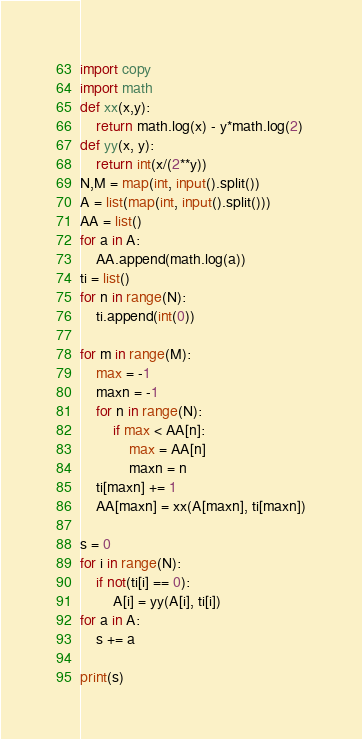Convert code to text. <code><loc_0><loc_0><loc_500><loc_500><_Python_>import copy
import math
def xx(x,y):
    return math.log(x) - y*math.log(2)
def yy(x, y):
    return int(x/(2**y))
N,M = map(int, input().split())
A = list(map(int, input().split()))
AA = list()
for a in A:
    AA.append(math.log(a))
ti = list()
for n in range(N):
    ti.append(int(0))

for m in range(M):
    max = -1
    maxn = -1
    for n in range(N):
        if max < AA[n]:
            max = AA[n]
            maxn = n
    ti[maxn] += 1
    AA[maxn] = xx(A[maxn], ti[maxn])

s = 0
for i in range(N):
    if not(ti[i] == 0):
        A[i] = yy(A[i], ti[i])
for a in A:
    s += a

print(s)</code> 